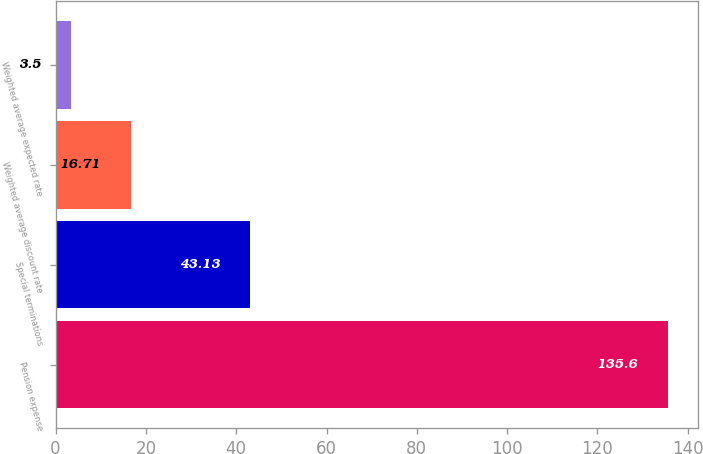<chart> <loc_0><loc_0><loc_500><loc_500><bar_chart><fcel>Pension expense<fcel>Special terminations<fcel>Weighted average discount rate<fcel>Weighted average expected rate<nl><fcel>135.6<fcel>43.13<fcel>16.71<fcel>3.5<nl></chart> 